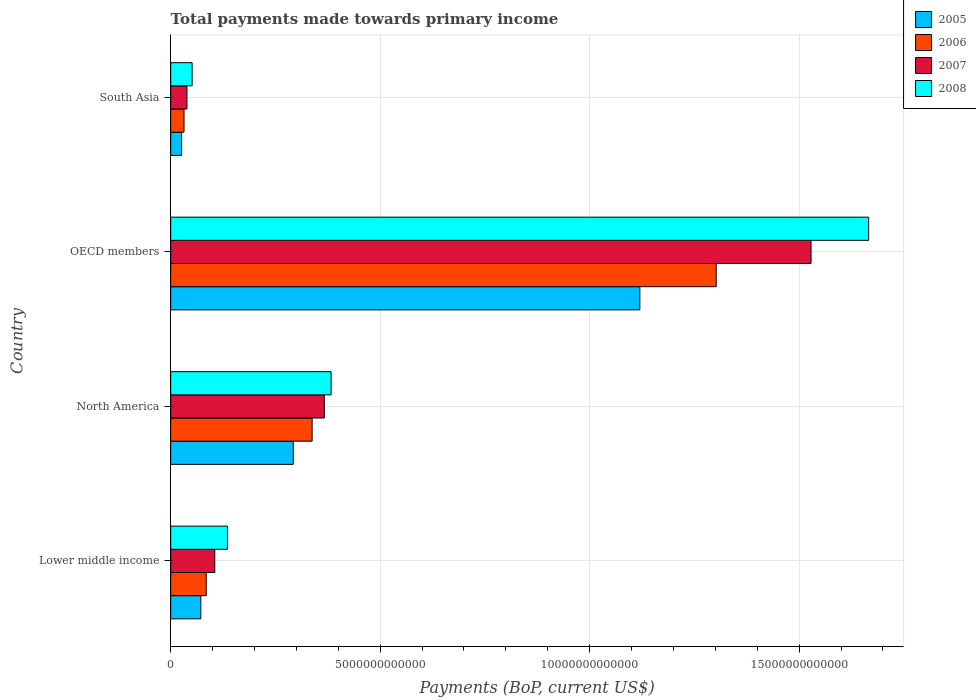Are the number of bars per tick equal to the number of legend labels?
Keep it short and to the point. Yes. Are the number of bars on each tick of the Y-axis equal?
Offer a very short reply. Yes. How many bars are there on the 3rd tick from the top?
Offer a terse response. 4. What is the label of the 1st group of bars from the top?
Give a very brief answer. South Asia. In how many cases, is the number of bars for a given country not equal to the number of legend labels?
Offer a terse response. 0. What is the total payments made towards primary income in 2005 in North America?
Your response must be concise. 2.93e+12. Across all countries, what is the maximum total payments made towards primary income in 2008?
Your response must be concise. 1.67e+13. Across all countries, what is the minimum total payments made towards primary income in 2006?
Make the answer very short. 3.18e+11. In which country was the total payments made towards primary income in 2008 maximum?
Provide a succinct answer. OECD members. In which country was the total payments made towards primary income in 2006 minimum?
Your answer should be compact. South Asia. What is the total total payments made towards primary income in 2005 in the graph?
Your response must be concise. 1.51e+13. What is the difference between the total payments made towards primary income in 2006 in Lower middle income and that in North America?
Your answer should be compact. -2.53e+12. What is the difference between the total payments made towards primary income in 2008 in OECD members and the total payments made towards primary income in 2005 in Lower middle income?
Give a very brief answer. 1.59e+13. What is the average total payments made towards primary income in 2005 per country?
Your answer should be very brief. 3.78e+12. What is the difference between the total payments made towards primary income in 2008 and total payments made towards primary income in 2006 in North America?
Provide a succinct answer. 4.53e+11. In how many countries, is the total payments made towards primary income in 2007 greater than 11000000000000 US$?
Ensure brevity in your answer.  1. What is the ratio of the total payments made towards primary income in 2007 in OECD members to that in South Asia?
Provide a short and direct response. 39.44. Is the total payments made towards primary income in 2006 in North America less than that in South Asia?
Keep it short and to the point. No. Is the difference between the total payments made towards primary income in 2008 in Lower middle income and OECD members greater than the difference between the total payments made towards primary income in 2006 in Lower middle income and OECD members?
Ensure brevity in your answer.  No. What is the difference between the highest and the second highest total payments made towards primary income in 2005?
Keep it short and to the point. 8.27e+12. What is the difference between the highest and the lowest total payments made towards primary income in 2005?
Make the answer very short. 1.09e+13. In how many countries, is the total payments made towards primary income in 2008 greater than the average total payments made towards primary income in 2008 taken over all countries?
Make the answer very short. 1. Is the sum of the total payments made towards primary income in 2007 in North America and South Asia greater than the maximum total payments made towards primary income in 2005 across all countries?
Give a very brief answer. No. Is it the case that in every country, the sum of the total payments made towards primary income in 2008 and total payments made towards primary income in 2007 is greater than the sum of total payments made towards primary income in 2005 and total payments made towards primary income in 2006?
Offer a very short reply. No. What does the 2nd bar from the top in Lower middle income represents?
Ensure brevity in your answer.  2007. What does the 4th bar from the bottom in Lower middle income represents?
Ensure brevity in your answer.  2008. Is it the case that in every country, the sum of the total payments made towards primary income in 2008 and total payments made towards primary income in 2005 is greater than the total payments made towards primary income in 2006?
Offer a terse response. Yes. How many bars are there?
Offer a very short reply. 16. Are all the bars in the graph horizontal?
Offer a very short reply. Yes. What is the difference between two consecutive major ticks on the X-axis?
Ensure brevity in your answer.  5.00e+12. Are the values on the major ticks of X-axis written in scientific E-notation?
Your response must be concise. No. Does the graph contain any zero values?
Your answer should be compact. No. How many legend labels are there?
Offer a very short reply. 4. What is the title of the graph?
Your answer should be compact. Total payments made towards primary income. Does "2000" appear as one of the legend labels in the graph?
Ensure brevity in your answer.  No. What is the label or title of the X-axis?
Provide a succinct answer. Payments (BoP, current US$). What is the label or title of the Y-axis?
Make the answer very short. Country. What is the Payments (BoP, current US$) in 2005 in Lower middle income?
Offer a terse response. 7.19e+11. What is the Payments (BoP, current US$) of 2006 in Lower middle income?
Offer a very short reply. 8.48e+11. What is the Payments (BoP, current US$) of 2007 in Lower middle income?
Provide a succinct answer. 1.05e+12. What is the Payments (BoP, current US$) in 2008 in Lower middle income?
Give a very brief answer. 1.35e+12. What is the Payments (BoP, current US$) in 2005 in North America?
Your response must be concise. 2.93e+12. What is the Payments (BoP, current US$) in 2006 in North America?
Your response must be concise. 3.38e+12. What is the Payments (BoP, current US$) of 2007 in North America?
Keep it short and to the point. 3.67e+12. What is the Payments (BoP, current US$) of 2008 in North America?
Offer a terse response. 3.83e+12. What is the Payments (BoP, current US$) of 2005 in OECD members?
Give a very brief answer. 1.12e+13. What is the Payments (BoP, current US$) in 2006 in OECD members?
Your response must be concise. 1.30e+13. What is the Payments (BoP, current US$) of 2007 in OECD members?
Keep it short and to the point. 1.53e+13. What is the Payments (BoP, current US$) in 2008 in OECD members?
Your response must be concise. 1.67e+13. What is the Payments (BoP, current US$) in 2005 in South Asia?
Make the answer very short. 2.61e+11. What is the Payments (BoP, current US$) of 2006 in South Asia?
Provide a succinct answer. 3.18e+11. What is the Payments (BoP, current US$) of 2007 in South Asia?
Your answer should be very brief. 3.88e+11. What is the Payments (BoP, current US$) in 2008 in South Asia?
Your answer should be compact. 5.11e+11. Across all countries, what is the maximum Payments (BoP, current US$) in 2005?
Make the answer very short. 1.12e+13. Across all countries, what is the maximum Payments (BoP, current US$) in 2006?
Give a very brief answer. 1.30e+13. Across all countries, what is the maximum Payments (BoP, current US$) of 2007?
Your answer should be very brief. 1.53e+13. Across all countries, what is the maximum Payments (BoP, current US$) of 2008?
Provide a short and direct response. 1.67e+13. Across all countries, what is the minimum Payments (BoP, current US$) of 2005?
Your answer should be compact. 2.61e+11. Across all countries, what is the minimum Payments (BoP, current US$) in 2006?
Your answer should be compact. 3.18e+11. Across all countries, what is the minimum Payments (BoP, current US$) of 2007?
Make the answer very short. 3.88e+11. Across all countries, what is the minimum Payments (BoP, current US$) in 2008?
Your response must be concise. 5.11e+11. What is the total Payments (BoP, current US$) in 2005 in the graph?
Offer a very short reply. 1.51e+13. What is the total Payments (BoP, current US$) in 2006 in the graph?
Provide a short and direct response. 1.76e+13. What is the total Payments (BoP, current US$) in 2007 in the graph?
Your answer should be very brief. 2.04e+13. What is the total Payments (BoP, current US$) in 2008 in the graph?
Your response must be concise. 2.24e+13. What is the difference between the Payments (BoP, current US$) in 2005 in Lower middle income and that in North America?
Provide a short and direct response. -2.21e+12. What is the difference between the Payments (BoP, current US$) in 2006 in Lower middle income and that in North America?
Your answer should be very brief. -2.53e+12. What is the difference between the Payments (BoP, current US$) of 2007 in Lower middle income and that in North America?
Offer a very short reply. -2.61e+12. What is the difference between the Payments (BoP, current US$) of 2008 in Lower middle income and that in North America?
Make the answer very short. -2.47e+12. What is the difference between the Payments (BoP, current US$) of 2005 in Lower middle income and that in OECD members?
Offer a very short reply. -1.05e+13. What is the difference between the Payments (BoP, current US$) of 2006 in Lower middle income and that in OECD members?
Offer a terse response. -1.22e+13. What is the difference between the Payments (BoP, current US$) in 2007 in Lower middle income and that in OECD members?
Give a very brief answer. -1.42e+13. What is the difference between the Payments (BoP, current US$) in 2008 in Lower middle income and that in OECD members?
Your answer should be very brief. -1.53e+13. What is the difference between the Payments (BoP, current US$) in 2005 in Lower middle income and that in South Asia?
Your answer should be compact. 4.59e+11. What is the difference between the Payments (BoP, current US$) of 2006 in Lower middle income and that in South Asia?
Your response must be concise. 5.30e+11. What is the difference between the Payments (BoP, current US$) of 2007 in Lower middle income and that in South Asia?
Your answer should be compact. 6.64e+11. What is the difference between the Payments (BoP, current US$) of 2008 in Lower middle income and that in South Asia?
Provide a succinct answer. 8.43e+11. What is the difference between the Payments (BoP, current US$) in 2005 in North America and that in OECD members?
Your response must be concise. -8.27e+12. What is the difference between the Payments (BoP, current US$) in 2006 in North America and that in OECD members?
Offer a very short reply. -9.65e+12. What is the difference between the Payments (BoP, current US$) in 2007 in North America and that in OECD members?
Offer a very short reply. -1.16e+13. What is the difference between the Payments (BoP, current US$) of 2008 in North America and that in OECD members?
Your response must be concise. -1.28e+13. What is the difference between the Payments (BoP, current US$) of 2005 in North America and that in South Asia?
Make the answer very short. 2.67e+12. What is the difference between the Payments (BoP, current US$) in 2006 in North America and that in South Asia?
Provide a short and direct response. 3.06e+12. What is the difference between the Payments (BoP, current US$) in 2007 in North America and that in South Asia?
Your answer should be compact. 3.28e+12. What is the difference between the Payments (BoP, current US$) in 2008 in North America and that in South Asia?
Provide a short and direct response. 3.32e+12. What is the difference between the Payments (BoP, current US$) of 2005 in OECD members and that in South Asia?
Your response must be concise. 1.09e+13. What is the difference between the Payments (BoP, current US$) in 2006 in OECD members and that in South Asia?
Ensure brevity in your answer.  1.27e+13. What is the difference between the Payments (BoP, current US$) of 2007 in OECD members and that in South Asia?
Offer a terse response. 1.49e+13. What is the difference between the Payments (BoP, current US$) of 2008 in OECD members and that in South Asia?
Keep it short and to the point. 1.61e+13. What is the difference between the Payments (BoP, current US$) in 2005 in Lower middle income and the Payments (BoP, current US$) in 2006 in North America?
Your response must be concise. -2.66e+12. What is the difference between the Payments (BoP, current US$) in 2005 in Lower middle income and the Payments (BoP, current US$) in 2007 in North America?
Give a very brief answer. -2.95e+12. What is the difference between the Payments (BoP, current US$) of 2005 in Lower middle income and the Payments (BoP, current US$) of 2008 in North America?
Provide a short and direct response. -3.11e+12. What is the difference between the Payments (BoP, current US$) in 2006 in Lower middle income and the Payments (BoP, current US$) in 2007 in North America?
Make the answer very short. -2.82e+12. What is the difference between the Payments (BoP, current US$) in 2006 in Lower middle income and the Payments (BoP, current US$) in 2008 in North America?
Your answer should be very brief. -2.98e+12. What is the difference between the Payments (BoP, current US$) in 2007 in Lower middle income and the Payments (BoP, current US$) in 2008 in North America?
Offer a very short reply. -2.78e+12. What is the difference between the Payments (BoP, current US$) in 2005 in Lower middle income and the Payments (BoP, current US$) in 2006 in OECD members?
Your answer should be compact. -1.23e+13. What is the difference between the Payments (BoP, current US$) in 2005 in Lower middle income and the Payments (BoP, current US$) in 2007 in OECD members?
Your response must be concise. -1.46e+13. What is the difference between the Payments (BoP, current US$) in 2005 in Lower middle income and the Payments (BoP, current US$) in 2008 in OECD members?
Your answer should be very brief. -1.59e+13. What is the difference between the Payments (BoP, current US$) in 2006 in Lower middle income and the Payments (BoP, current US$) in 2007 in OECD members?
Offer a very short reply. -1.44e+13. What is the difference between the Payments (BoP, current US$) in 2006 in Lower middle income and the Payments (BoP, current US$) in 2008 in OECD members?
Ensure brevity in your answer.  -1.58e+13. What is the difference between the Payments (BoP, current US$) in 2007 in Lower middle income and the Payments (BoP, current US$) in 2008 in OECD members?
Provide a short and direct response. -1.56e+13. What is the difference between the Payments (BoP, current US$) of 2005 in Lower middle income and the Payments (BoP, current US$) of 2006 in South Asia?
Offer a terse response. 4.01e+11. What is the difference between the Payments (BoP, current US$) in 2005 in Lower middle income and the Payments (BoP, current US$) in 2007 in South Asia?
Ensure brevity in your answer.  3.32e+11. What is the difference between the Payments (BoP, current US$) in 2005 in Lower middle income and the Payments (BoP, current US$) in 2008 in South Asia?
Provide a succinct answer. 2.08e+11. What is the difference between the Payments (BoP, current US$) of 2006 in Lower middle income and the Payments (BoP, current US$) of 2007 in South Asia?
Give a very brief answer. 4.60e+11. What is the difference between the Payments (BoP, current US$) in 2006 in Lower middle income and the Payments (BoP, current US$) in 2008 in South Asia?
Provide a succinct answer. 3.37e+11. What is the difference between the Payments (BoP, current US$) of 2007 in Lower middle income and the Payments (BoP, current US$) of 2008 in South Asia?
Offer a very short reply. 5.41e+11. What is the difference between the Payments (BoP, current US$) of 2005 in North America and the Payments (BoP, current US$) of 2006 in OECD members?
Ensure brevity in your answer.  -1.01e+13. What is the difference between the Payments (BoP, current US$) in 2005 in North America and the Payments (BoP, current US$) in 2007 in OECD members?
Provide a succinct answer. -1.24e+13. What is the difference between the Payments (BoP, current US$) of 2005 in North America and the Payments (BoP, current US$) of 2008 in OECD members?
Your answer should be compact. -1.37e+13. What is the difference between the Payments (BoP, current US$) of 2006 in North America and the Payments (BoP, current US$) of 2007 in OECD members?
Keep it short and to the point. -1.19e+13. What is the difference between the Payments (BoP, current US$) in 2006 in North America and the Payments (BoP, current US$) in 2008 in OECD members?
Offer a very short reply. -1.33e+13. What is the difference between the Payments (BoP, current US$) of 2007 in North America and the Payments (BoP, current US$) of 2008 in OECD members?
Your answer should be compact. -1.30e+13. What is the difference between the Payments (BoP, current US$) of 2005 in North America and the Payments (BoP, current US$) of 2006 in South Asia?
Your response must be concise. 2.61e+12. What is the difference between the Payments (BoP, current US$) of 2005 in North America and the Payments (BoP, current US$) of 2007 in South Asia?
Give a very brief answer. 2.54e+12. What is the difference between the Payments (BoP, current US$) of 2005 in North America and the Payments (BoP, current US$) of 2008 in South Asia?
Offer a very short reply. 2.41e+12. What is the difference between the Payments (BoP, current US$) in 2006 in North America and the Payments (BoP, current US$) in 2007 in South Asia?
Provide a short and direct response. 2.99e+12. What is the difference between the Payments (BoP, current US$) of 2006 in North America and the Payments (BoP, current US$) of 2008 in South Asia?
Provide a succinct answer. 2.86e+12. What is the difference between the Payments (BoP, current US$) of 2007 in North America and the Payments (BoP, current US$) of 2008 in South Asia?
Provide a short and direct response. 3.15e+12. What is the difference between the Payments (BoP, current US$) in 2005 in OECD members and the Payments (BoP, current US$) in 2006 in South Asia?
Provide a short and direct response. 1.09e+13. What is the difference between the Payments (BoP, current US$) of 2005 in OECD members and the Payments (BoP, current US$) of 2007 in South Asia?
Offer a terse response. 1.08e+13. What is the difference between the Payments (BoP, current US$) in 2005 in OECD members and the Payments (BoP, current US$) in 2008 in South Asia?
Ensure brevity in your answer.  1.07e+13. What is the difference between the Payments (BoP, current US$) in 2006 in OECD members and the Payments (BoP, current US$) in 2007 in South Asia?
Offer a very short reply. 1.26e+13. What is the difference between the Payments (BoP, current US$) in 2006 in OECD members and the Payments (BoP, current US$) in 2008 in South Asia?
Ensure brevity in your answer.  1.25e+13. What is the difference between the Payments (BoP, current US$) of 2007 in OECD members and the Payments (BoP, current US$) of 2008 in South Asia?
Your answer should be compact. 1.48e+13. What is the average Payments (BoP, current US$) of 2005 per country?
Offer a terse response. 3.78e+12. What is the average Payments (BoP, current US$) in 2006 per country?
Your response must be concise. 4.39e+12. What is the average Payments (BoP, current US$) of 2007 per country?
Your answer should be very brief. 5.10e+12. What is the average Payments (BoP, current US$) of 2008 per country?
Your response must be concise. 5.59e+12. What is the difference between the Payments (BoP, current US$) in 2005 and Payments (BoP, current US$) in 2006 in Lower middle income?
Ensure brevity in your answer.  -1.29e+11. What is the difference between the Payments (BoP, current US$) of 2005 and Payments (BoP, current US$) of 2007 in Lower middle income?
Provide a short and direct response. -3.33e+11. What is the difference between the Payments (BoP, current US$) in 2005 and Payments (BoP, current US$) in 2008 in Lower middle income?
Make the answer very short. -6.35e+11. What is the difference between the Payments (BoP, current US$) in 2006 and Payments (BoP, current US$) in 2007 in Lower middle income?
Offer a terse response. -2.04e+11. What is the difference between the Payments (BoP, current US$) of 2006 and Payments (BoP, current US$) of 2008 in Lower middle income?
Give a very brief answer. -5.07e+11. What is the difference between the Payments (BoP, current US$) of 2007 and Payments (BoP, current US$) of 2008 in Lower middle income?
Your response must be concise. -3.03e+11. What is the difference between the Payments (BoP, current US$) of 2005 and Payments (BoP, current US$) of 2006 in North America?
Ensure brevity in your answer.  -4.49e+11. What is the difference between the Payments (BoP, current US$) in 2005 and Payments (BoP, current US$) in 2007 in North America?
Provide a short and direct response. -7.40e+11. What is the difference between the Payments (BoP, current US$) in 2005 and Payments (BoP, current US$) in 2008 in North America?
Your answer should be compact. -9.02e+11. What is the difference between the Payments (BoP, current US$) in 2006 and Payments (BoP, current US$) in 2007 in North America?
Provide a succinct answer. -2.91e+11. What is the difference between the Payments (BoP, current US$) in 2006 and Payments (BoP, current US$) in 2008 in North America?
Offer a terse response. -4.53e+11. What is the difference between the Payments (BoP, current US$) in 2007 and Payments (BoP, current US$) in 2008 in North America?
Your response must be concise. -1.62e+11. What is the difference between the Payments (BoP, current US$) in 2005 and Payments (BoP, current US$) in 2006 in OECD members?
Provide a succinct answer. -1.82e+12. What is the difference between the Payments (BoP, current US$) of 2005 and Payments (BoP, current US$) of 2007 in OECD members?
Ensure brevity in your answer.  -4.09e+12. What is the difference between the Payments (BoP, current US$) in 2005 and Payments (BoP, current US$) in 2008 in OECD members?
Make the answer very short. -5.46e+12. What is the difference between the Payments (BoP, current US$) in 2006 and Payments (BoP, current US$) in 2007 in OECD members?
Give a very brief answer. -2.26e+12. What is the difference between the Payments (BoP, current US$) of 2006 and Payments (BoP, current US$) of 2008 in OECD members?
Make the answer very short. -3.64e+12. What is the difference between the Payments (BoP, current US$) of 2007 and Payments (BoP, current US$) of 2008 in OECD members?
Your answer should be compact. -1.38e+12. What is the difference between the Payments (BoP, current US$) of 2005 and Payments (BoP, current US$) of 2006 in South Asia?
Offer a very short reply. -5.75e+1. What is the difference between the Payments (BoP, current US$) in 2005 and Payments (BoP, current US$) in 2007 in South Asia?
Make the answer very short. -1.27e+11. What is the difference between the Payments (BoP, current US$) in 2005 and Payments (BoP, current US$) in 2008 in South Asia?
Your answer should be compact. -2.51e+11. What is the difference between the Payments (BoP, current US$) in 2006 and Payments (BoP, current US$) in 2007 in South Asia?
Offer a very short reply. -6.95e+1. What is the difference between the Payments (BoP, current US$) of 2006 and Payments (BoP, current US$) of 2008 in South Asia?
Your answer should be compact. -1.93e+11. What is the difference between the Payments (BoP, current US$) in 2007 and Payments (BoP, current US$) in 2008 in South Asia?
Provide a short and direct response. -1.24e+11. What is the ratio of the Payments (BoP, current US$) of 2005 in Lower middle income to that in North America?
Keep it short and to the point. 0.25. What is the ratio of the Payments (BoP, current US$) in 2006 in Lower middle income to that in North America?
Provide a short and direct response. 0.25. What is the ratio of the Payments (BoP, current US$) of 2007 in Lower middle income to that in North America?
Your answer should be very brief. 0.29. What is the ratio of the Payments (BoP, current US$) in 2008 in Lower middle income to that in North America?
Give a very brief answer. 0.35. What is the ratio of the Payments (BoP, current US$) of 2005 in Lower middle income to that in OECD members?
Offer a terse response. 0.06. What is the ratio of the Payments (BoP, current US$) of 2006 in Lower middle income to that in OECD members?
Provide a short and direct response. 0.07. What is the ratio of the Payments (BoP, current US$) in 2007 in Lower middle income to that in OECD members?
Provide a short and direct response. 0.07. What is the ratio of the Payments (BoP, current US$) in 2008 in Lower middle income to that in OECD members?
Your answer should be compact. 0.08. What is the ratio of the Payments (BoP, current US$) of 2005 in Lower middle income to that in South Asia?
Offer a very short reply. 2.76. What is the ratio of the Payments (BoP, current US$) of 2006 in Lower middle income to that in South Asia?
Provide a succinct answer. 2.67. What is the ratio of the Payments (BoP, current US$) in 2007 in Lower middle income to that in South Asia?
Provide a short and direct response. 2.71. What is the ratio of the Payments (BoP, current US$) of 2008 in Lower middle income to that in South Asia?
Provide a succinct answer. 2.65. What is the ratio of the Payments (BoP, current US$) of 2005 in North America to that in OECD members?
Make the answer very short. 0.26. What is the ratio of the Payments (BoP, current US$) in 2006 in North America to that in OECD members?
Offer a very short reply. 0.26. What is the ratio of the Payments (BoP, current US$) of 2007 in North America to that in OECD members?
Ensure brevity in your answer.  0.24. What is the ratio of the Payments (BoP, current US$) in 2008 in North America to that in OECD members?
Your answer should be very brief. 0.23. What is the ratio of the Payments (BoP, current US$) of 2005 in North America to that in South Asia?
Provide a short and direct response. 11.23. What is the ratio of the Payments (BoP, current US$) of 2006 in North America to that in South Asia?
Your response must be concise. 10.61. What is the ratio of the Payments (BoP, current US$) in 2007 in North America to that in South Asia?
Your response must be concise. 9.46. What is the ratio of the Payments (BoP, current US$) in 2008 in North America to that in South Asia?
Keep it short and to the point. 7.49. What is the ratio of the Payments (BoP, current US$) of 2005 in OECD members to that in South Asia?
Provide a short and direct response. 42.99. What is the ratio of the Payments (BoP, current US$) of 2006 in OECD members to that in South Asia?
Make the answer very short. 40.95. What is the ratio of the Payments (BoP, current US$) of 2007 in OECD members to that in South Asia?
Provide a succinct answer. 39.44. What is the ratio of the Payments (BoP, current US$) of 2008 in OECD members to that in South Asia?
Your answer should be compact. 32.59. What is the difference between the highest and the second highest Payments (BoP, current US$) in 2005?
Ensure brevity in your answer.  8.27e+12. What is the difference between the highest and the second highest Payments (BoP, current US$) of 2006?
Make the answer very short. 9.65e+12. What is the difference between the highest and the second highest Payments (BoP, current US$) of 2007?
Your response must be concise. 1.16e+13. What is the difference between the highest and the second highest Payments (BoP, current US$) of 2008?
Keep it short and to the point. 1.28e+13. What is the difference between the highest and the lowest Payments (BoP, current US$) of 2005?
Offer a very short reply. 1.09e+13. What is the difference between the highest and the lowest Payments (BoP, current US$) of 2006?
Offer a very short reply. 1.27e+13. What is the difference between the highest and the lowest Payments (BoP, current US$) of 2007?
Keep it short and to the point. 1.49e+13. What is the difference between the highest and the lowest Payments (BoP, current US$) of 2008?
Keep it short and to the point. 1.61e+13. 